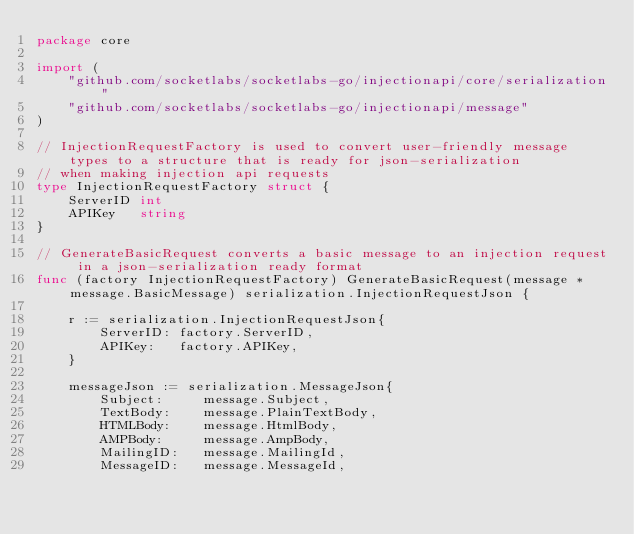<code> <loc_0><loc_0><loc_500><loc_500><_Go_>package core

import (
	"github.com/socketlabs/socketlabs-go/injectionapi/core/serialization"
	"github.com/socketlabs/socketlabs-go/injectionapi/message"
)

// InjectionRequestFactory is used to convert user-friendly message types to a structure that is ready for json-serialization
// when making injection api requests
type InjectionRequestFactory struct {
	ServerID int
	APIKey   string
}

// GenerateBasicRequest converts a basic message to an injection request in a json-serialization ready format
func (factory InjectionRequestFactory) GenerateBasicRequest(message *message.BasicMessage) serialization.InjectionRequestJson {

	r := serialization.InjectionRequestJson{
		ServerID: factory.ServerID,
		APIKey:   factory.APIKey,
	}

	messageJson := serialization.MessageJson{
		Subject:     message.Subject,
		TextBody:    message.PlainTextBody,
		HTMLBody:    message.HtmlBody,
		AMPBody:     message.AmpBody,
		MailingID:   message.MailingId,
		MessageID:   message.MessageId,</code> 